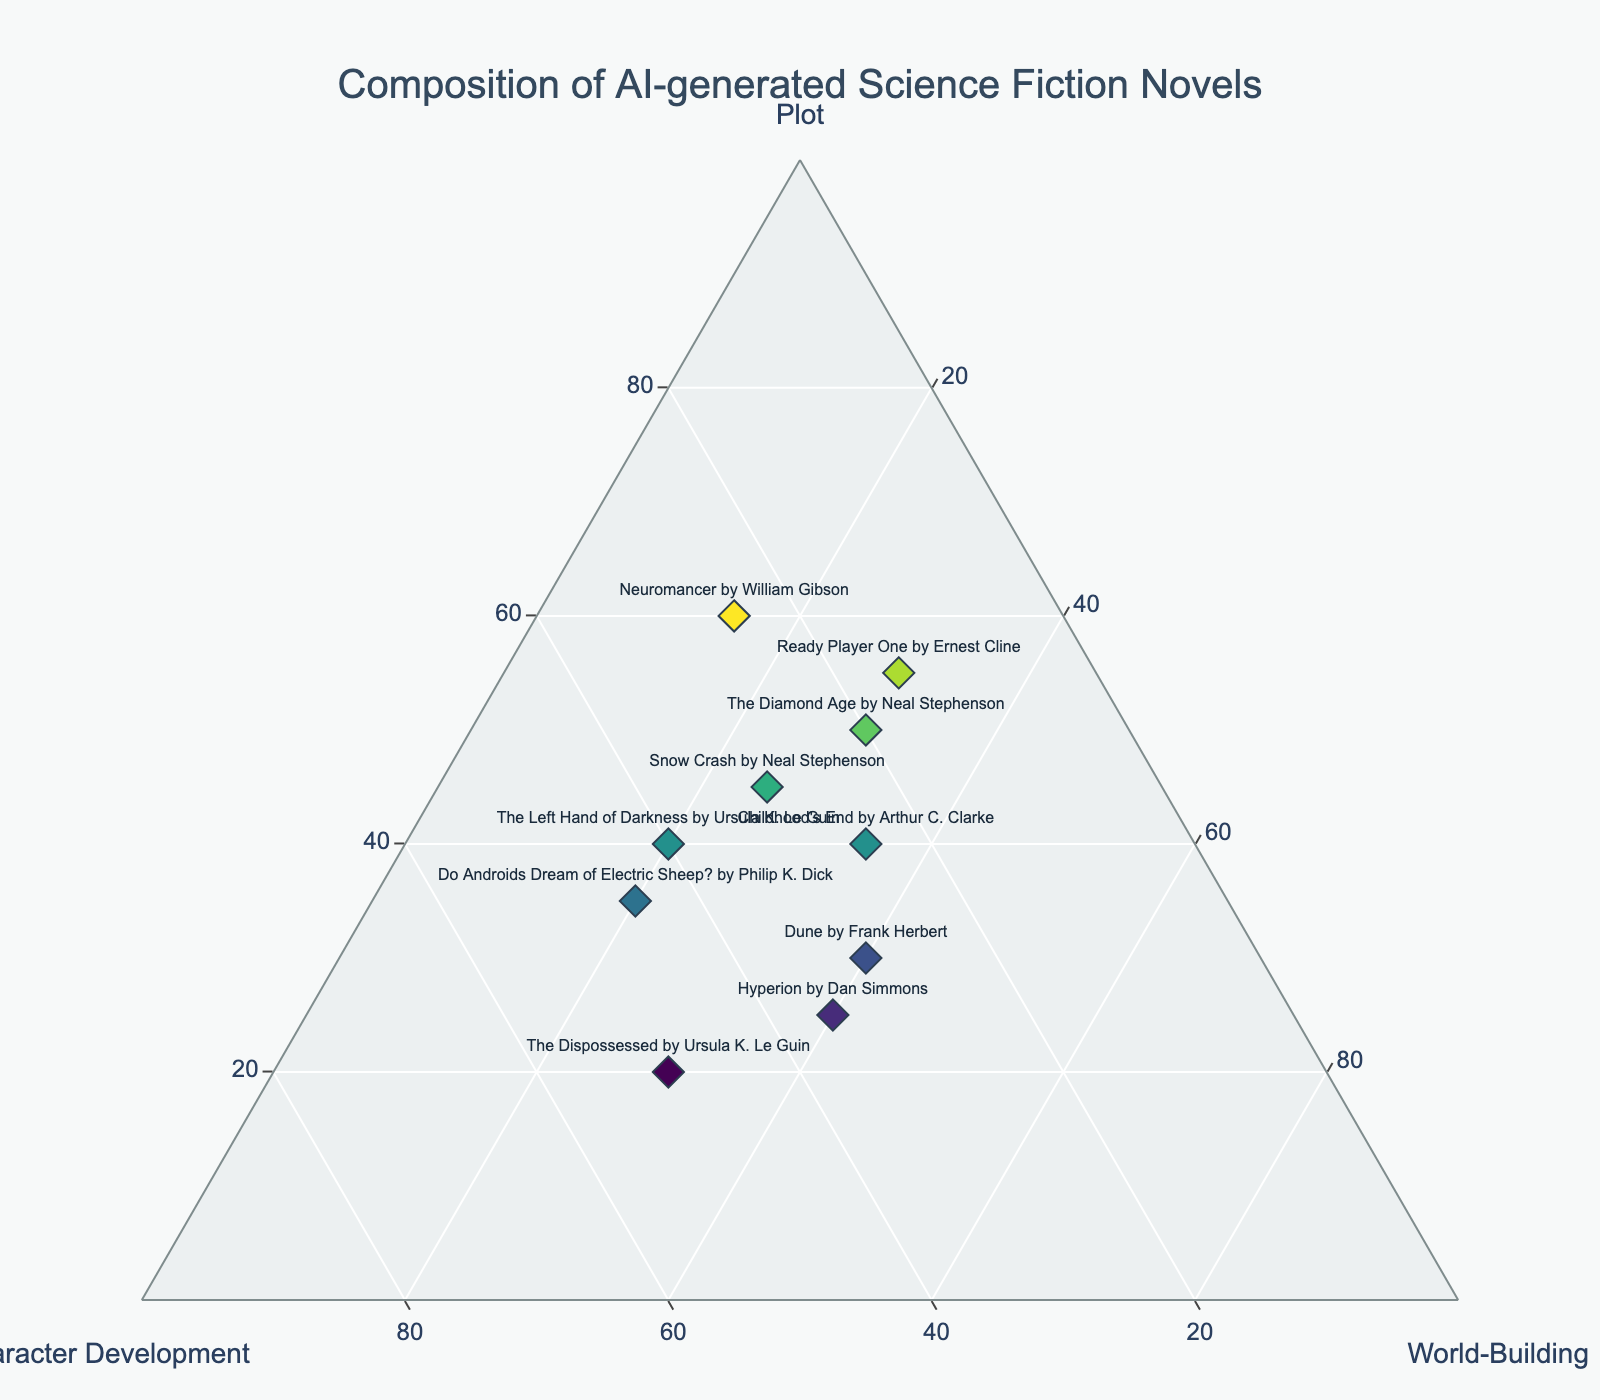What is the title of this figure? The title is displayed at the top center of the figure. It reads "Composition of AI-generated Science Fiction Novels".
Answer: Composition of AI-generated Science Fiction Novels What novel has the highest percentage of plot elements? By inspecting the plot axis, "Neuromancer by William Gibson" has the highest percentage of plot elements at 60%.
Answer: Neuromancer by William Gibson Which novel is most balanced in terms of plot, character development, and world-building? The novel with the most balanced percentages across all three elements is "Dune by Frank Herbert", with 30% plot, 30% character development, and 40% world-building.
Answer: Dune by Frank Herbert How many novels have more than 40% character development? By looking at the character development axis, "The Left Hand of Darkness", "Do Androids Dream of Electric Sheep?", and "The Dispossessed" each have more than 40% character development. That's a total of 3 novels.
Answer: 3 Which novel has the closest proportion of plot and world-building? "Ready Player One by Ernest Cline" has 55% plot and 30% world-building, showing a closer proportion compared to others with a larger difference between these two elements.
Answer: Ready Player One by Ernest Cline Which novel has the highest percentage of world-building elements? "Hyperion by Dan Simmons" has the highest percentage of world-building elements at 40%.
Answer: Hyperion by Dan Simmons Compare the plot composition between "Neuromancer" and "The Dispossessed". Which one is higher? "Neuromancer by William Gibson" has 60% plot, whereas "The Dispossessed by Ursula K. Le Guin" has 20% plot. "Neuromancer" has a higher plot composition.
Answer: Neuromancer by William Gibson What is the average percentage of plot for the novels listed? Sum the plot percentages for all novels (60 + 40 + 30 + 50 + 35 + 25 + 45 + 20 + 55 + 40) = 400, and divide by the number of novels (10). The average percentage of plot is 40%.
Answer: 40% Which novel has the highest overall balance between character development and world-building alone, and what are their percentages? By examining the character development and world-building values, "Ready Player One by Ernest Cline" has a relatively close balance with 15% character development and 30% world-building.
Answer: Ready Player One by Ernest Cline 